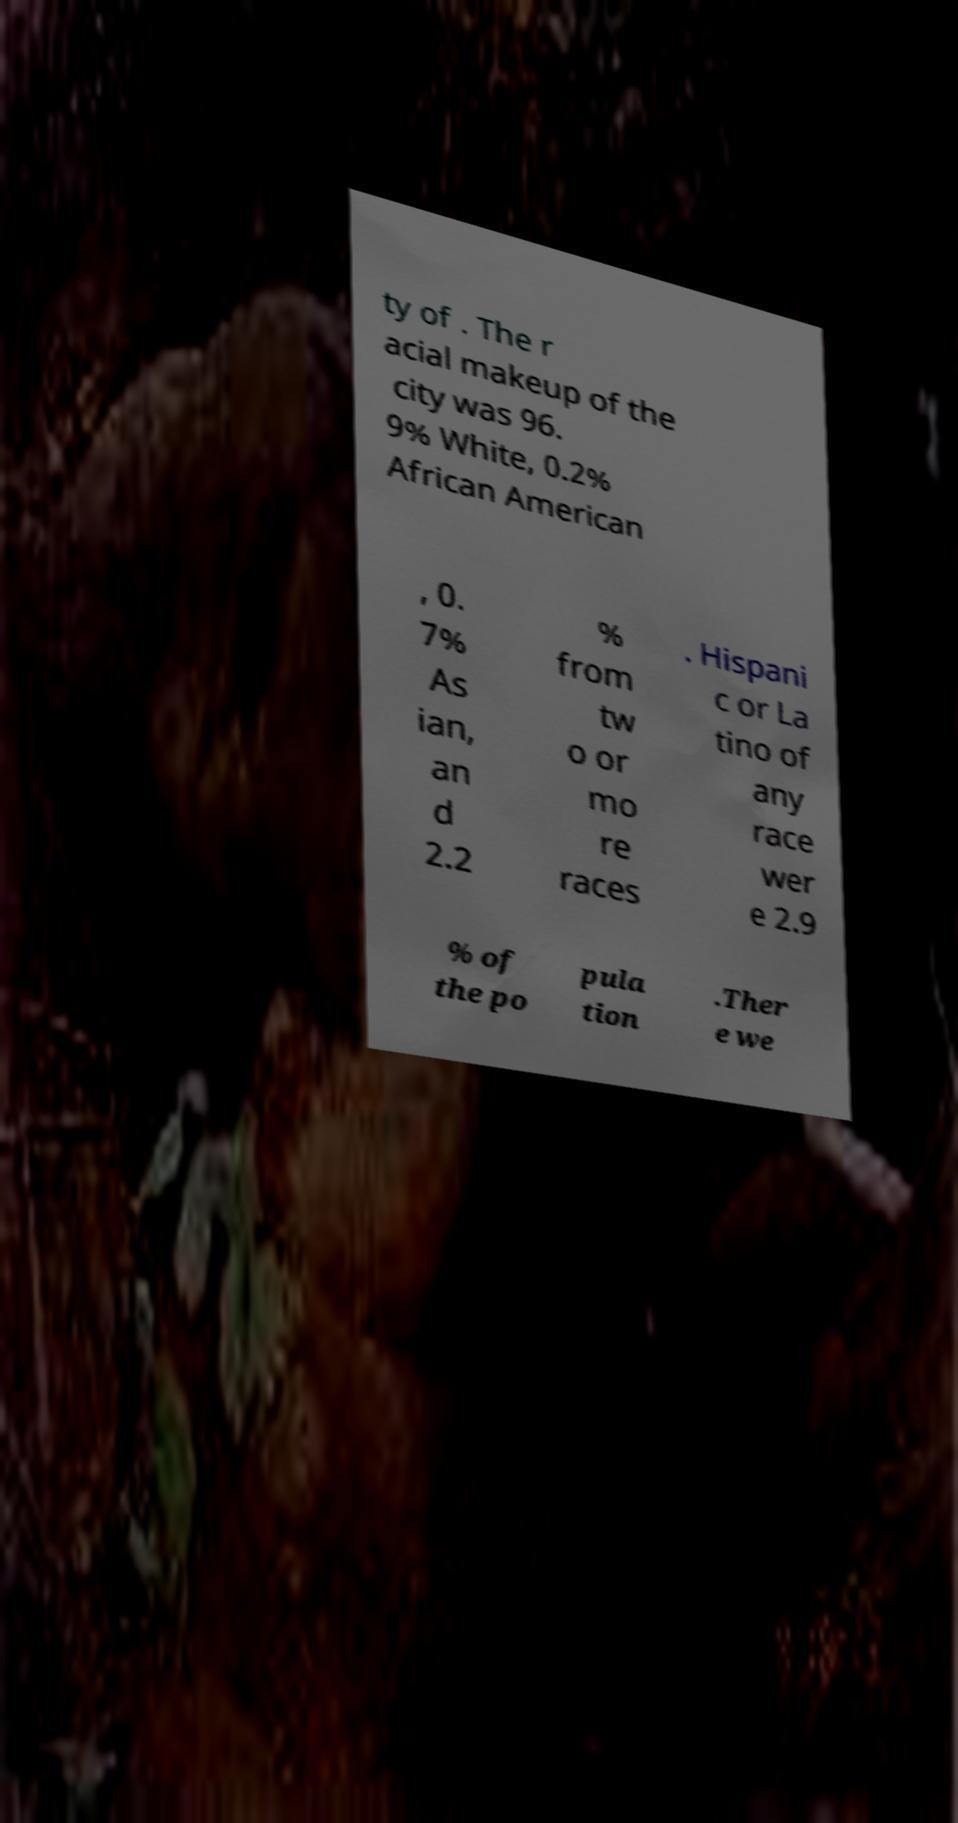Please read and relay the text visible in this image. What does it say? ty of . The r acial makeup of the city was 96. 9% White, 0.2% African American , 0. 7% As ian, an d 2.2 % from tw o or mo re races . Hispani c or La tino of any race wer e 2.9 % of the po pula tion .Ther e we 